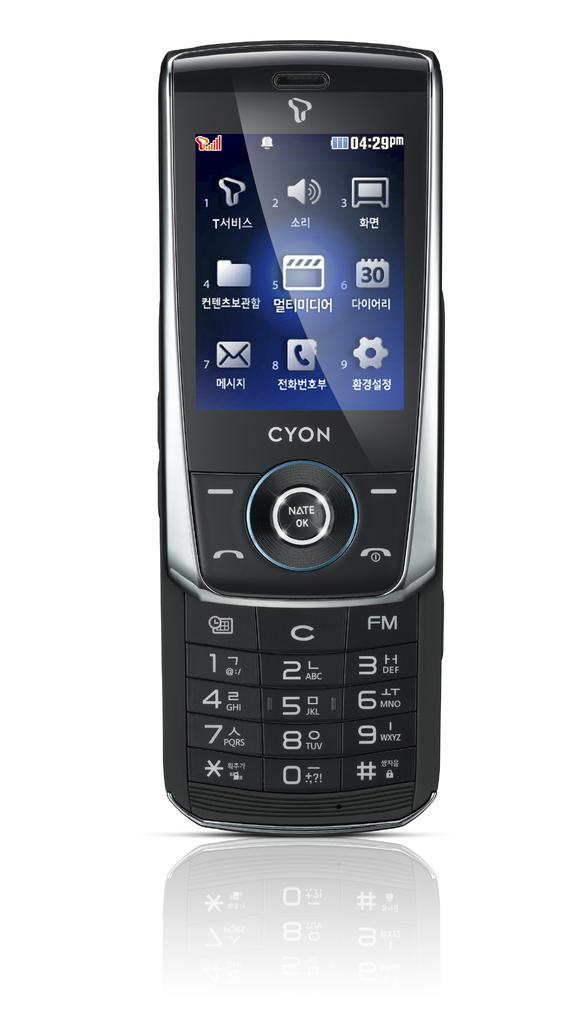<image>
Relay a brief, clear account of the picture shown. a Cyon trac phone with a built in keyboard 